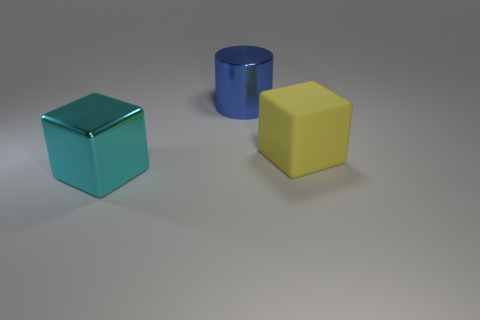Are these objects arranged in a pattern or random order? The objects are placed in a staggered arrangement with no discernible pattern. They are spaced apart, with each object resting independently on the flat surface. The configuration seems random without any specific order or alignment. 